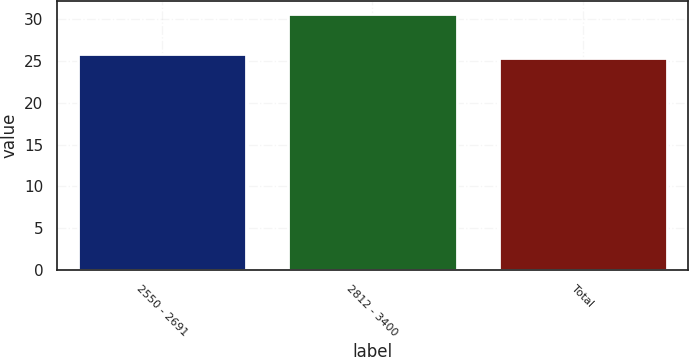Convert chart. <chart><loc_0><loc_0><loc_500><loc_500><bar_chart><fcel>2550 - 2691<fcel>2812 - 3400<fcel>Total<nl><fcel>25.89<fcel>30.62<fcel>25.37<nl></chart> 